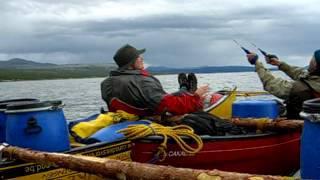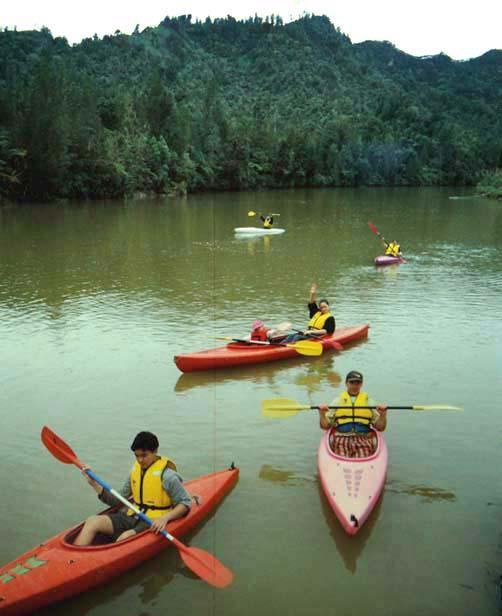The first image is the image on the left, the second image is the image on the right. Analyze the images presented: Is the assertion "Multiple canoes are headed away from the camera in one image." valid? Answer yes or no. No. The first image is the image on the left, the second image is the image on the right. Considering the images on both sides, is "There are people using red paddles." valid? Answer yes or no. Yes. 